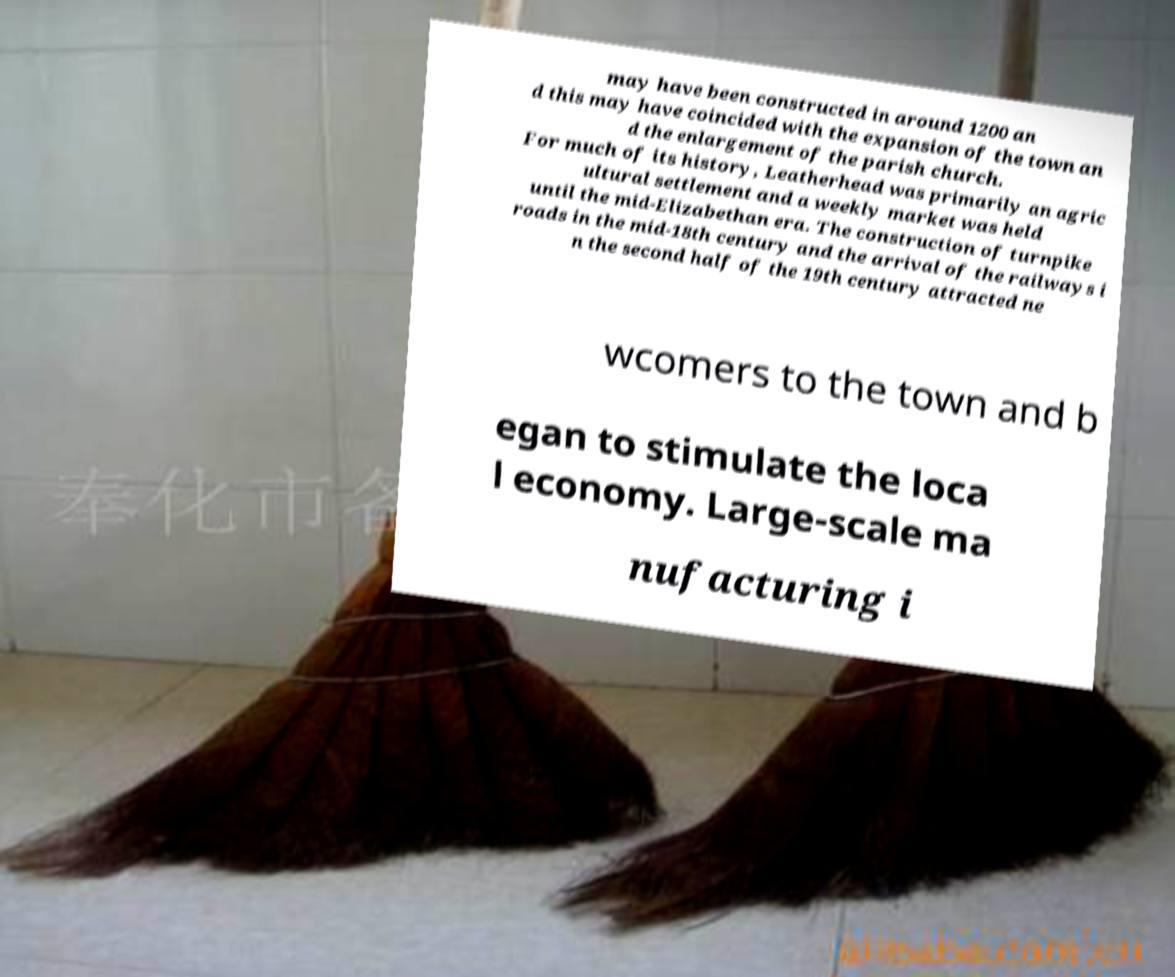Can you read and provide the text displayed in the image?This photo seems to have some interesting text. Can you extract and type it out for me? may have been constructed in around 1200 an d this may have coincided with the expansion of the town an d the enlargement of the parish church. For much of its history, Leatherhead was primarily an agric ultural settlement and a weekly market was held until the mid-Elizabethan era. The construction of turnpike roads in the mid-18th century and the arrival of the railways i n the second half of the 19th century attracted ne wcomers to the town and b egan to stimulate the loca l economy. Large-scale ma nufacturing i 